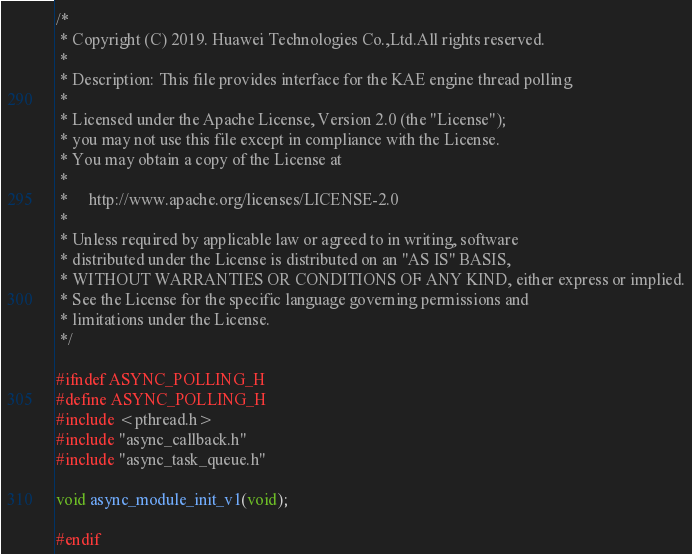<code> <loc_0><loc_0><loc_500><loc_500><_C_>/*
 * Copyright (C) 2019. Huawei Technologies Co.,Ltd.All rights reserved.
 *
 * Description: This file provides interface for the KAE engine thread polling
 *
 * Licensed under the Apache License, Version 2.0 (the "License");
 * you may not use this file except in compliance with the License.
 * You may obtain a copy of the License at
 *
 *     http://www.apache.org/licenses/LICENSE-2.0
 *
 * Unless required by applicable law or agreed to in writing, software
 * distributed under the License is distributed on an "AS IS" BASIS,
 * WITHOUT WARRANTIES OR CONDITIONS OF ANY KIND, either express or implied.
 * See the License for the specific language governing permissions and
 * limitations under the License.
 */

#ifndef ASYNC_POLLING_H
#define ASYNC_POLLING_H
#include <pthread.h>
#include "async_callback.h"
#include "async_task_queue.h"

void async_module_init_v1(void);

#endif

</code> 